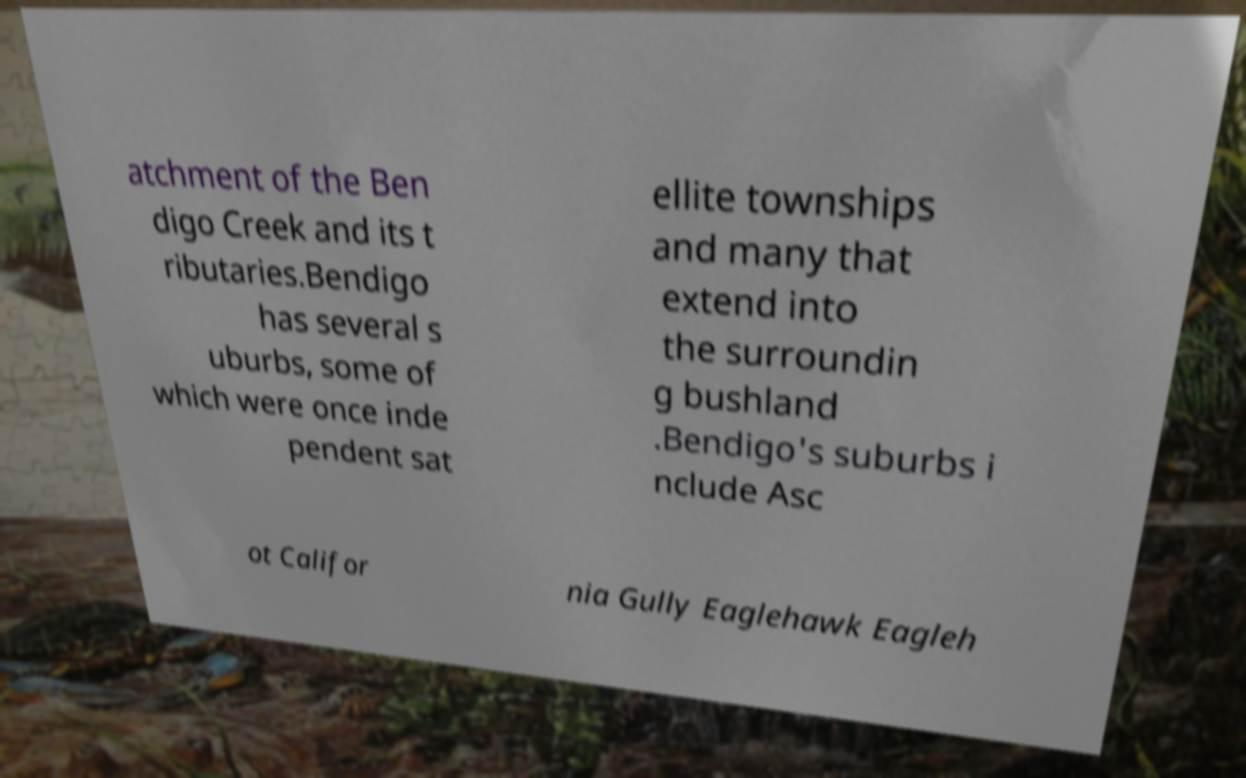For documentation purposes, I need the text within this image transcribed. Could you provide that? atchment of the Ben digo Creek and its t ributaries.Bendigo has several s uburbs, some of which were once inde pendent sat ellite townships and many that extend into the surroundin g bushland .Bendigo's suburbs i nclude Asc ot Califor nia Gully Eaglehawk Eagleh 